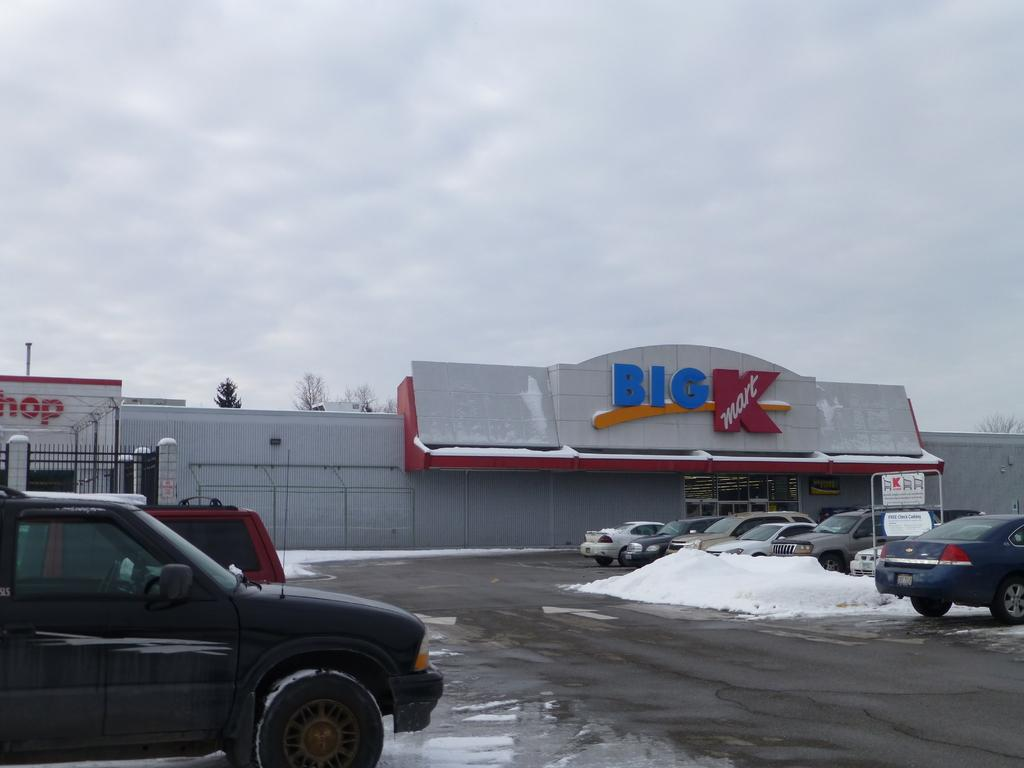What type of vehicles can be seen on the road in the image? There are cars on the road in the image. What weather condition is depicted in the image? There is snow visible in the image. What type of structures can be seen in the image? There are buildings in the image. What type of vegetation can be seen in the image? There are trees in the image. What is visible in the background of the image? The sky is visible in the background of the image. What can be seen in the sky? Clouds are present in the sky. How many pins are holding the rainstorm in place in the image? There is no rainstorm present in the image, and therefore no pins holding it in place. What type of dust can be seen covering the trees in the image? There is no dust visible in the image; the trees are covered in snow. 